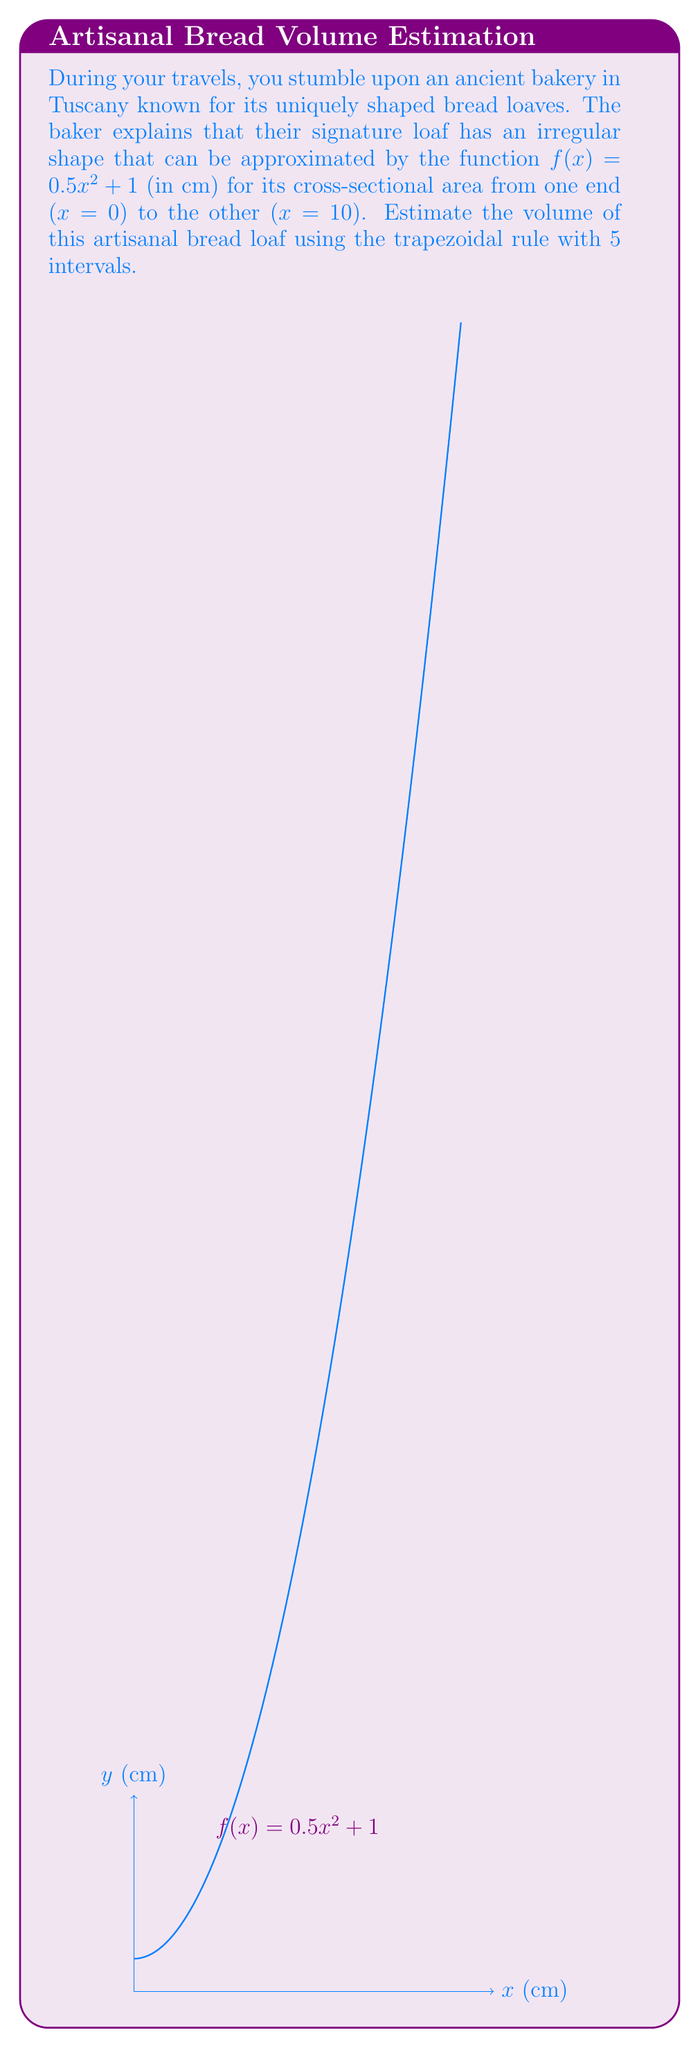Help me with this question. To estimate the volume using the trapezoidal rule with 5 intervals:

1) The interval $[0,10]$ is divided into 5 equal subintervals, each of width $h = \frac{10-0}{5} = 2$ cm.

2) The x-coordinates of the endpoints of these subintervals are:
   $x_0 = 0, x_1 = 2, x_2 = 4, x_3 = 6, x_4 = 8, x_5 = 10$

3) Calculate $f(x)$ for each x-coordinate:
   $f(0) = 1$
   $f(2) = 0.5(2)^2 + 1 = 3$
   $f(4) = 0.5(4)^2 + 1 = 9$
   $f(6) = 0.5(6)^2 + 1 = 19$
   $f(8) = 0.5(8)^2 + 1 = 33$
   $f(10) = 0.5(10)^2 + 1 = 51$

4) Apply the trapezoidal rule formula:
   $$V \approx \frac{h}{2}[f(x_0) + 2f(x_1) + 2f(x_2) + 2f(x_3) + 2f(x_4) + f(x_5)]$$

5) Substitute the values:
   $$V \approx \frac{2}{2}[1 + 2(3) + 2(9) + 2(19) + 2(33) + 51]$$
   $$V \approx 1[1 + 6 + 18 + 38 + 66 + 51]$$
   $$V \approx 180\text{ cm}^3$$

Thus, the estimated volume of the bread loaf is approximately 180 cubic centimeters.
Answer: $180\text{ cm}^3$ 